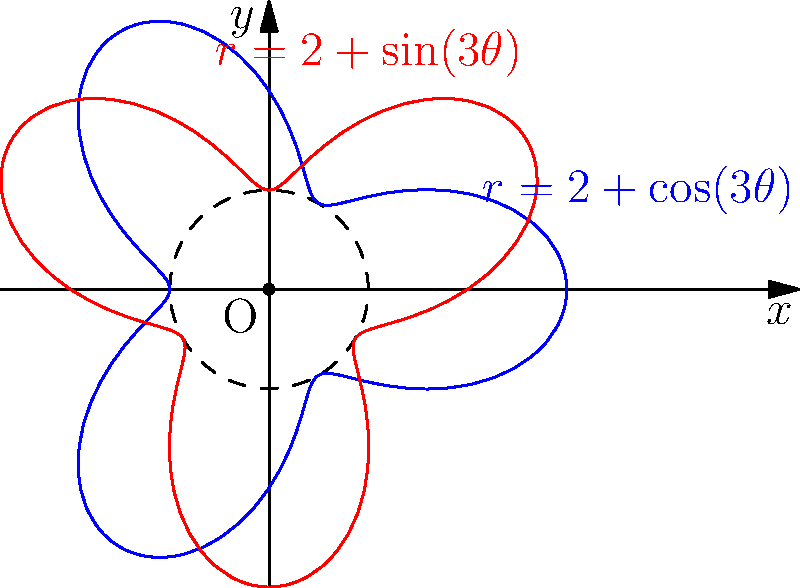As a funding agency representative evaluating a materials research proposal, you encounter a study on nanoparticle distribution in a circular sample. The researchers describe two different distribution patterns using polar coordinates: $r=2+\cos(3\theta)$ and $r=2+\sin(3\theta)$. What is the maximum radial distance from the center where nanoparticles can be found for both distributions, and how does this information contribute to understanding the material's properties? To solve this problem, we need to follow these steps:

1) The radial distance in both equations is given by $r = 2 + f(\theta)$, where $f(\theta)$ is either $\cos(3\theta)$ or $\sin(3\theta)$.

2) The maximum value of both cosine and sine functions is 1, and their minimum value is -1.

3) For $r = 2 + \cos(3\theta)$:
   - Maximum $r$ occurs when $\cos(3\theta) = 1$, so $r_{max} = 2 + 1 = 3$
   - Minimum $r$ occurs when $\cos(3\theta) = -1$, so $r_{min} = 2 - 1 = 1$

4) For $r = 2 + \sin(3\theta)$:
   - Maximum $r$ occurs when $\sin(3\theta) = 1$, so $r_{max} = 2 + 1 = 3$
   - Minimum $r$ occurs when $\sin(3\theta) = -1$, so $r_{min} = 2 - 1 = 1$

5) Therefore, for both distributions, the maximum radial distance from the center where nanoparticles can be found is 3 units.

6) This information contributes to understanding the material's properties by:
   a) Indicating the extent of nanoparticle spread, which affects the material's overall composition and behavior.
   b) Revealing symmetry in the distribution, which can influence physical and chemical properties.
   c) Providing insights into the manufacturing process and potential applications of the material.
   d) Allowing for comparison between different nanoparticle distributions and their effects on material properties.
Answer: 3 units; informs material composition, symmetry, manufacturing, and potential applications. 